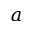<formula> <loc_0><loc_0><loc_500><loc_500>a</formula> 